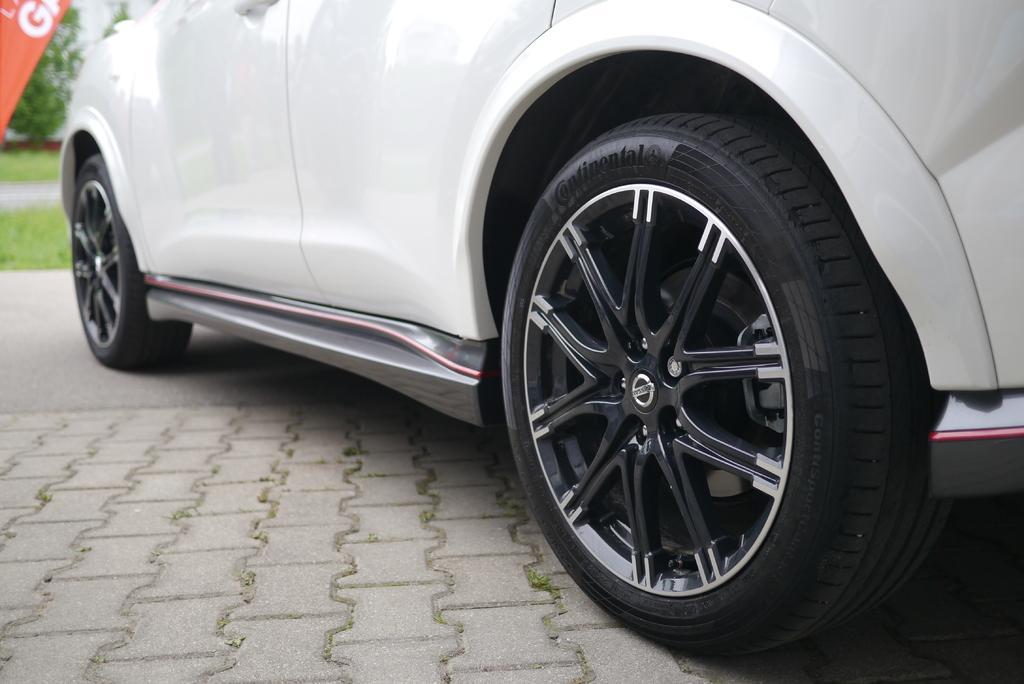How would you summarize this image in a sentence or two? In this picture there is a white car on the road. In the background there is a building. On the left we can see the posters, plants and grass. 